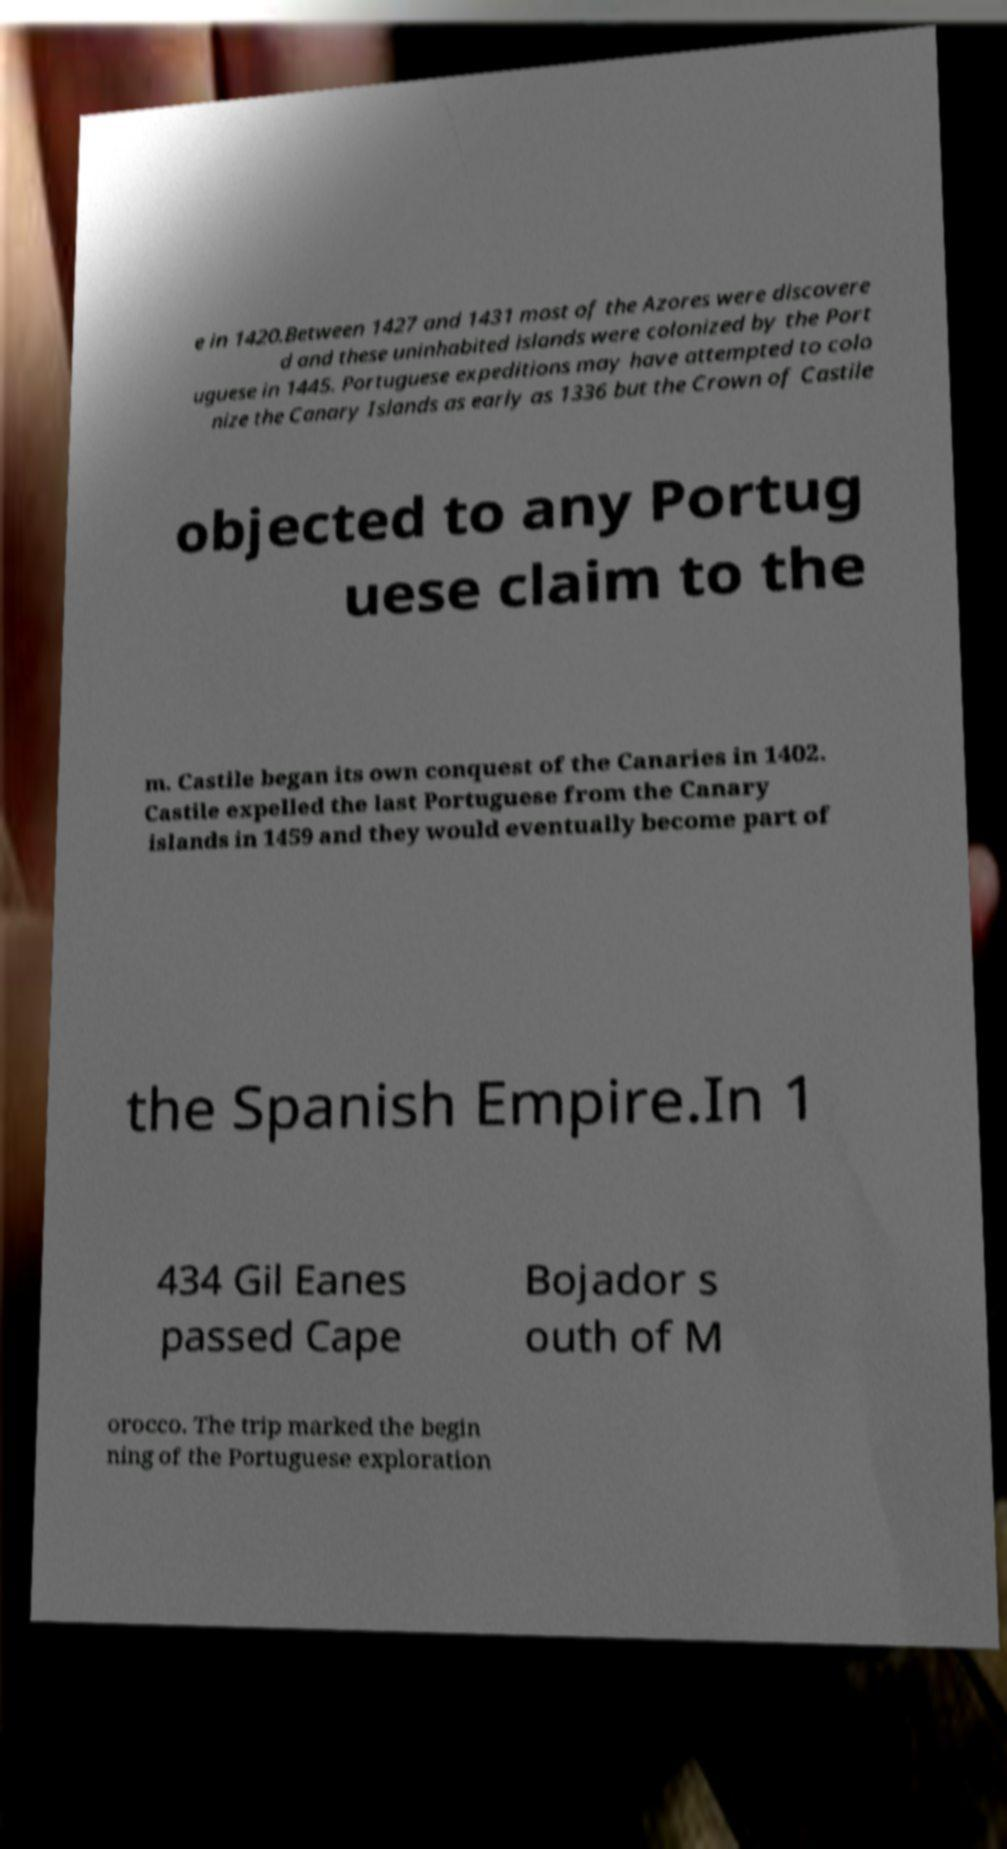Please identify and transcribe the text found in this image. e in 1420.Between 1427 and 1431 most of the Azores were discovere d and these uninhabited islands were colonized by the Port uguese in 1445. Portuguese expeditions may have attempted to colo nize the Canary Islands as early as 1336 but the Crown of Castile objected to any Portug uese claim to the m. Castile began its own conquest of the Canaries in 1402. Castile expelled the last Portuguese from the Canary islands in 1459 and they would eventually become part of the Spanish Empire.In 1 434 Gil Eanes passed Cape Bojador s outh of M orocco. The trip marked the begin ning of the Portuguese exploration 